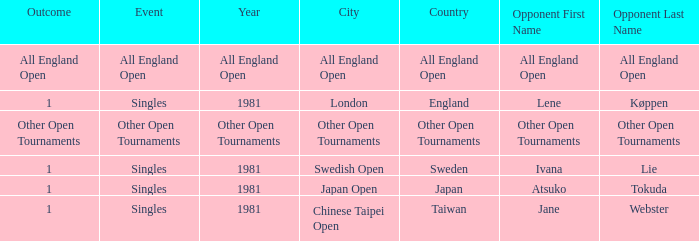Who was the Opponent in London, England with an Outcome of 1? Lene Køppen. 